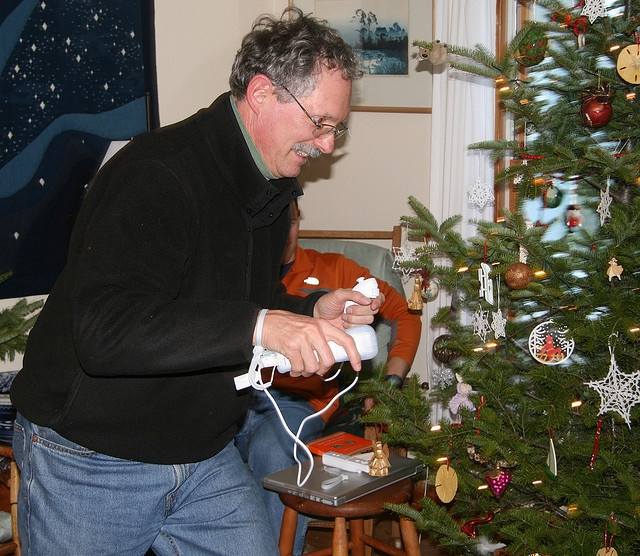Describe the objects in this image and their specific colors. I can see people in black, gray, and lightpink tones, people in black, brown, and maroon tones, chair in black, gray, brown, and darkgray tones, remote in black, white, lightpink, and darkgray tones, and book in black, brown, red, and olive tones in this image. 